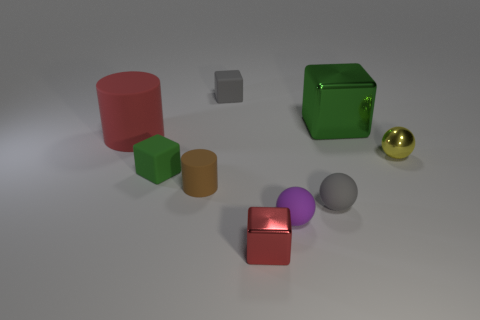Subtract all tiny purple matte spheres. How many spheres are left? 2 Subtract all red cylinders. How many cylinders are left? 1 Subtract 2 spheres. How many spheres are left? 1 Subtract 1 green blocks. How many objects are left? 8 Subtract all spheres. How many objects are left? 6 Subtract all blue spheres. Subtract all blue cylinders. How many spheres are left? 3 Subtract all brown cubes. How many brown cylinders are left? 1 Subtract all small gray objects. Subtract all rubber things. How many objects are left? 1 Add 6 gray matte blocks. How many gray matte blocks are left? 7 Add 3 large brown blocks. How many large brown blocks exist? 3 